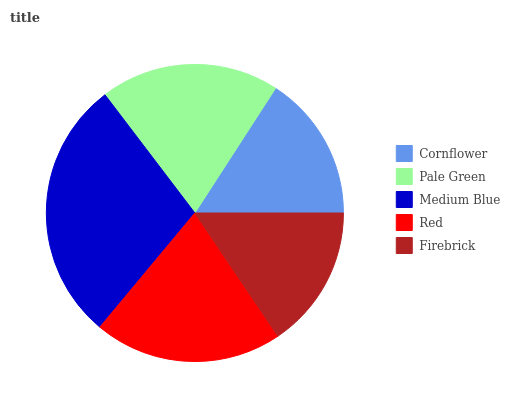Is Firebrick the minimum?
Answer yes or no. Yes. Is Medium Blue the maximum?
Answer yes or no. Yes. Is Pale Green the minimum?
Answer yes or no. No. Is Pale Green the maximum?
Answer yes or no. No. Is Pale Green greater than Cornflower?
Answer yes or no. Yes. Is Cornflower less than Pale Green?
Answer yes or no. Yes. Is Cornflower greater than Pale Green?
Answer yes or no. No. Is Pale Green less than Cornflower?
Answer yes or no. No. Is Pale Green the high median?
Answer yes or no. Yes. Is Pale Green the low median?
Answer yes or no. Yes. Is Firebrick the high median?
Answer yes or no. No. Is Cornflower the low median?
Answer yes or no. No. 